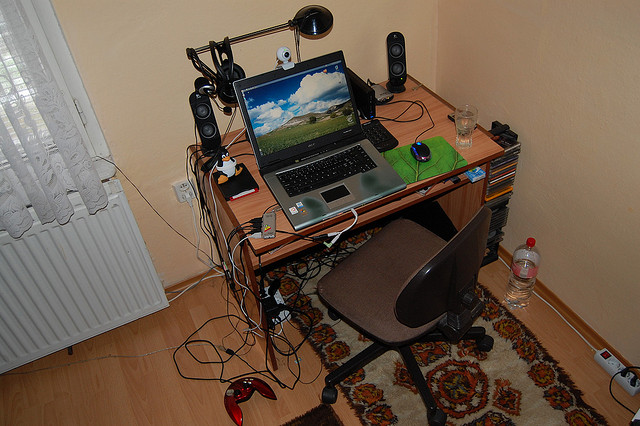<image>What is the title of the green book? There is no green book in the image. What is the title of the green book? There is no green book in the image. 